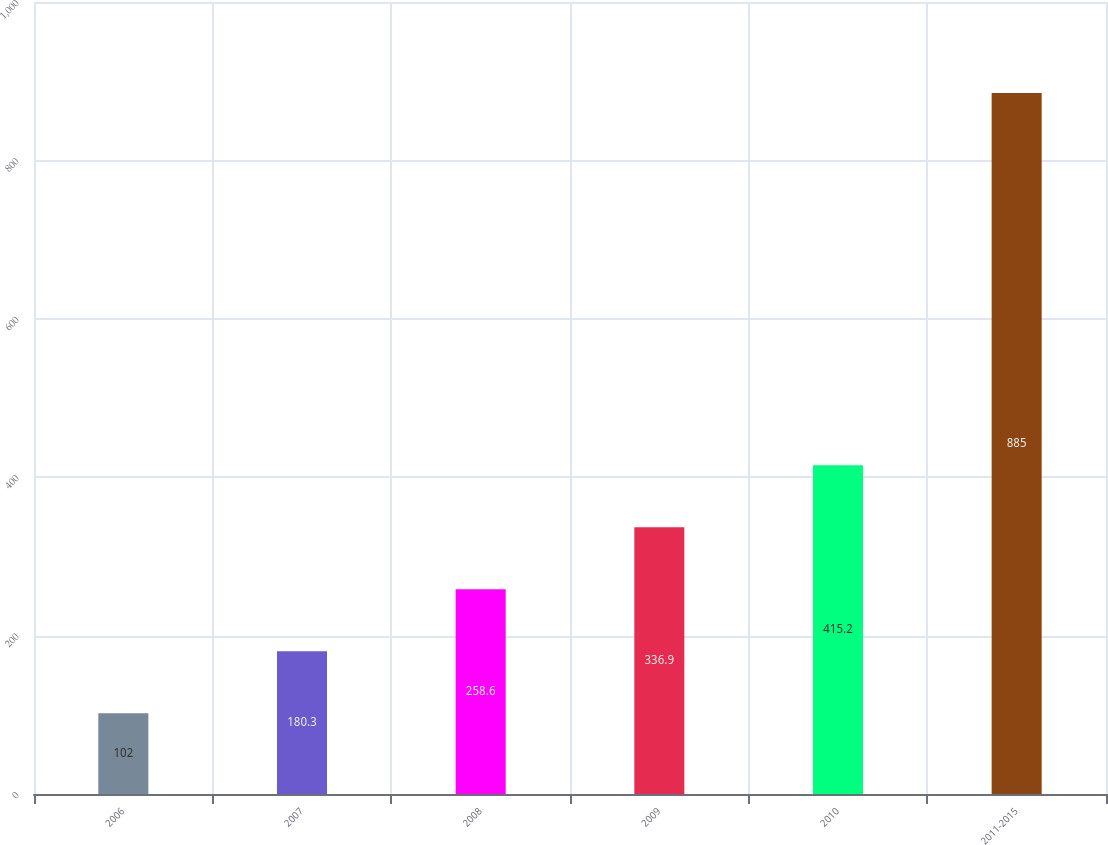Convert chart. <chart><loc_0><loc_0><loc_500><loc_500><bar_chart><fcel>2006<fcel>2007<fcel>2008<fcel>2009<fcel>2010<fcel>2011-2015<nl><fcel>102<fcel>180.3<fcel>258.6<fcel>336.9<fcel>415.2<fcel>885<nl></chart> 